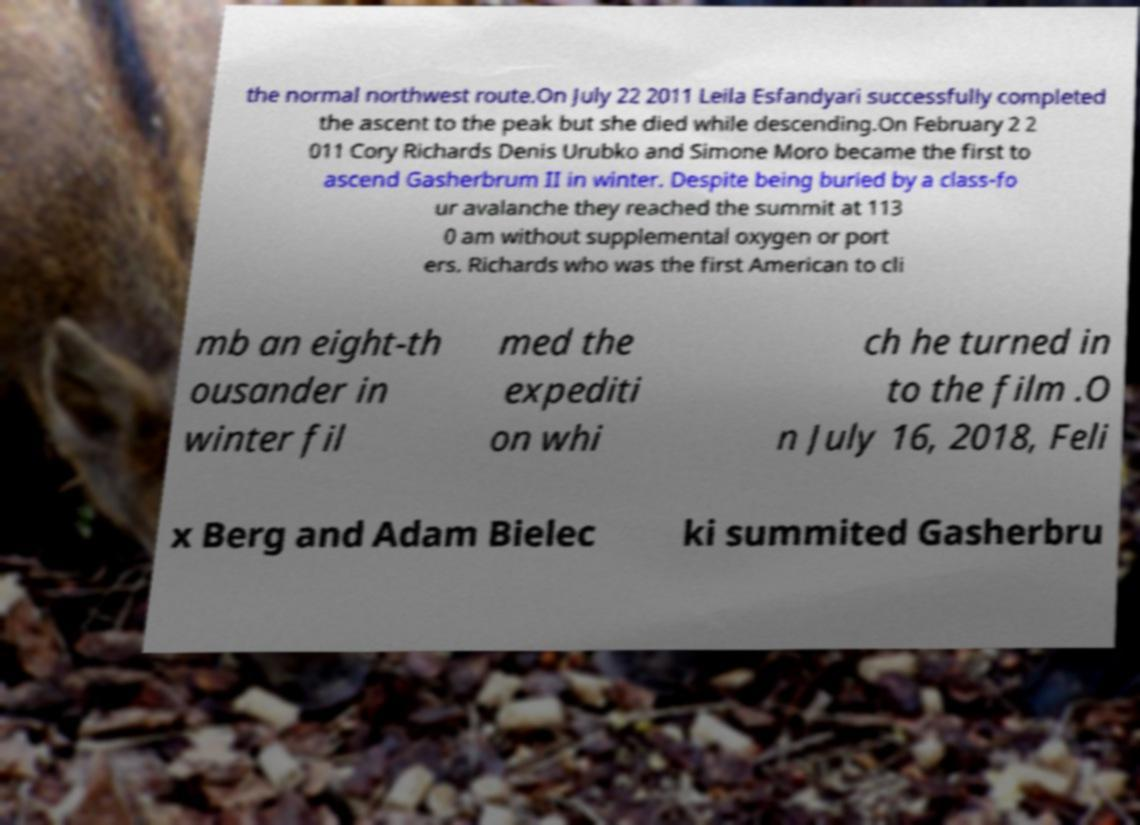Can you accurately transcribe the text from the provided image for me? the normal northwest route.On July 22 2011 Leila Esfandyari successfully completed the ascent to the peak but she died while descending.On February 2 2 011 Cory Richards Denis Urubko and Simone Moro became the first to ascend Gasherbrum II in winter. Despite being buried by a class-fo ur avalanche they reached the summit at 113 0 am without supplemental oxygen or port ers. Richards who was the first American to cli mb an eight-th ousander in winter fil med the expediti on whi ch he turned in to the film .O n July 16, 2018, Feli x Berg and Adam Bielec ki summited Gasherbru 